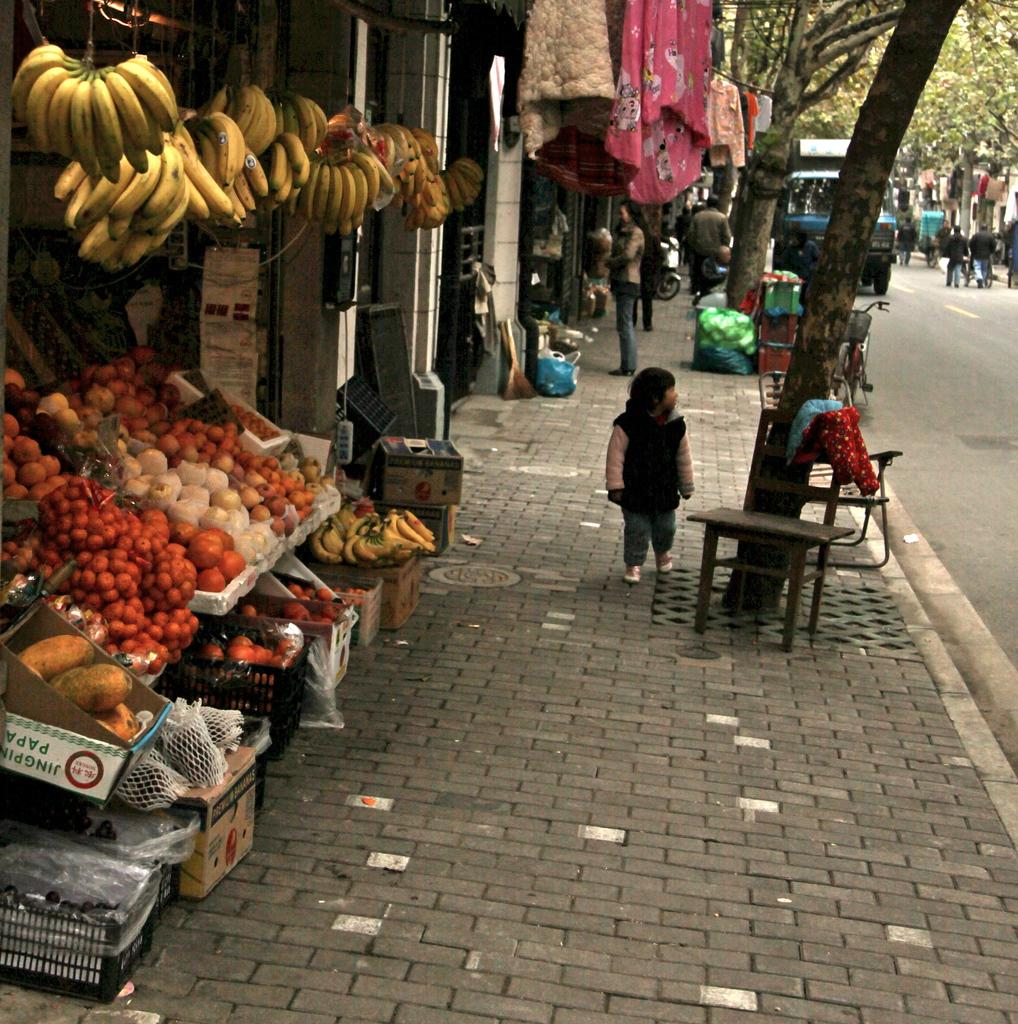What type of food items can be seen in the image? There are fruits in the image. What containers are present in the image? There are baskets and boxes in the image. Can you describe the pathway in the image? There is a footpath in the image. What type of transportation route is visible in the image? There is a road in the image. What natural elements can be seen in the image? There are trees in the image. What personal items are visible in the image? There are clothes in the image. What piece of furniture is present in the image? There is a table in the image. What mode of transportation can be seen in the image? There is a bicycle in the image. What type of vehicles are present in the image? There are vehicles in the image. Are there any other objects visible in the image? Yes, there are other objects in the image. What type of stem can be seen growing from the quartz in the image? There is no stem or quartz present in the image. What type of market can be seen in the background of the image? There is no market visible in the image. 